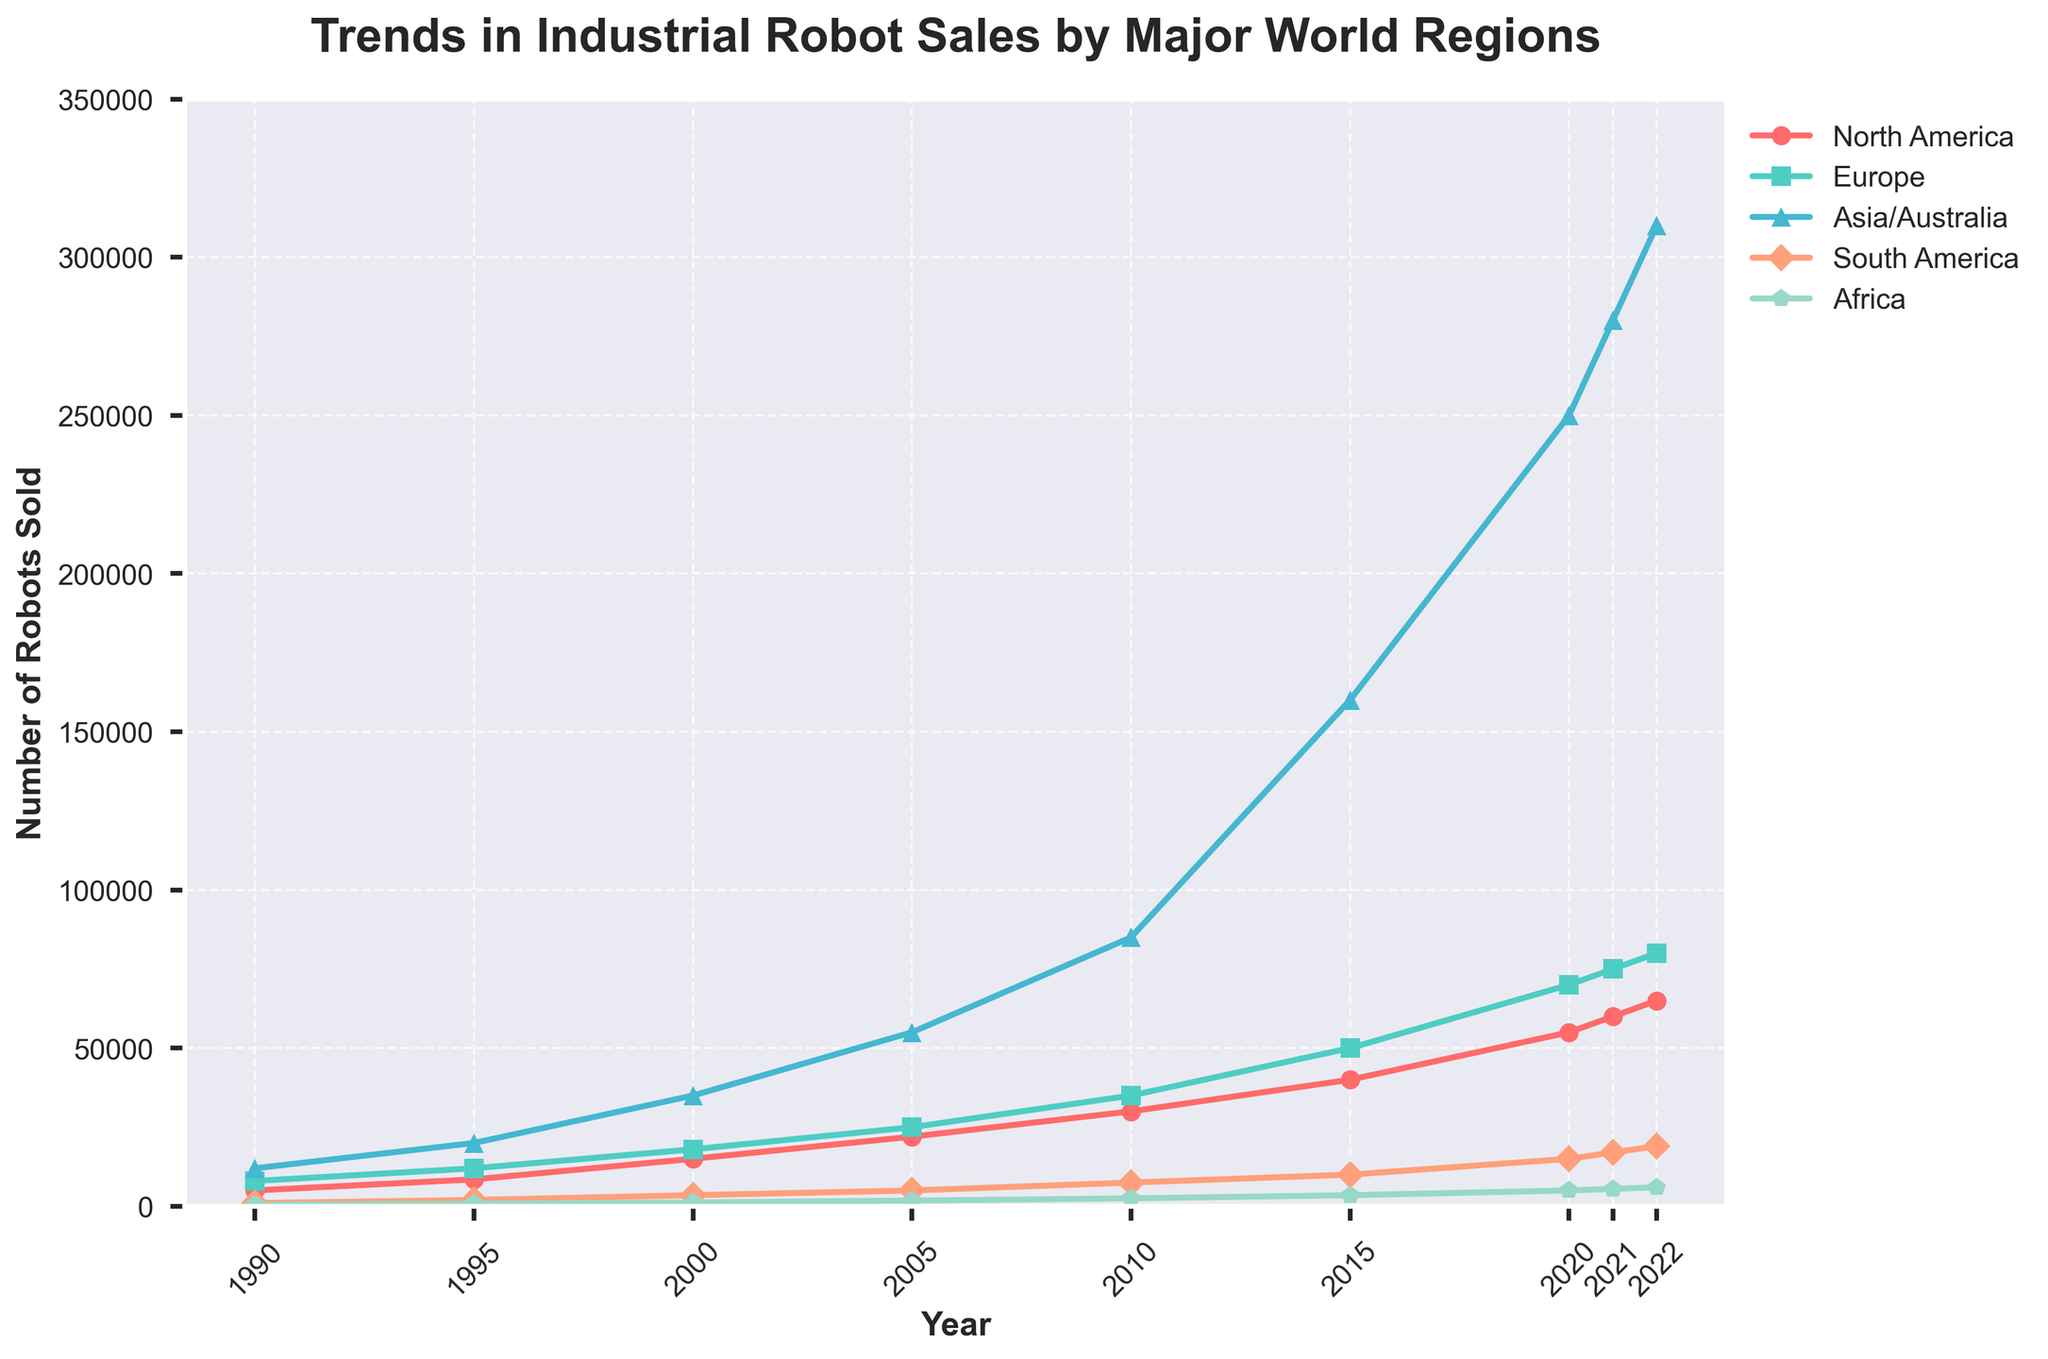What's the trend in industrial robot sales in Asia/Australia from 1990 to 2022? Examine the line for Asia/Australia, which starts at 12,000 in 1990 and ends at 310,000 in 2022, showing a consistent and steep increase over the period.
Answer: Increasing Which region had the highest growth in robot sales between 1995 and 2000? To find the region with the highest growth, calculate the difference between 2000 and 1995 for each region. Asia/Australia had the highest increase, from 20,000 to 35,000, an increment of 15,000.
Answer: Asia/Australia Between 2010 and 2015, which regions had an increase in robot sales? By comparing the data between 2010 and 2015: North America (30,000 to 40,000), Europe (35,000 to 50,000), Asia/Australia (85,000 to 160,000), South America (7,500 to 10,000), and Africa (2,500 to 3,500). All regions show an increase.
Answer: North America, Europe, Asia/Australia, South America, Africa What's the difference in robot sales between Europe and South America in 2020? Comparing the figures for 2020: Europe (70,000) and South America (15,000). Subtract the two to get the difference: 70,000 - 15,000 = 55,000.
Answer: 55,000 Throughout the years, which region always had the lowest robot sales? By observing the trends visually, Africa consistently had the lowest sales figures from 1990 to 2022.
Answer: Africa How does the robot sales trend in North America compare visually to Europe? Both North America and Europe show an increasing trend, but Europe's sales are consistently higher than North America's throughout the period, with both regions showing the steepest rise after 2005.
Answer: Europe's sales are higher and both are increasing In which year did Asia/Australia surpass 100,000 robot sales? Following the line for Asia/Australia, it crosses the 100,000 mark between 2010 (85,000) and 2015 (160,000). Hence, it surpasses 100,000 in 2015.
Answer: 2015 Which region showed the most dramatic increase in robot sales after 2005? Comparing the slopes of the lines post-2005, Asia/Australia exhibits the most dramatic increase, going from 55,000 in 2005 to 310,000 in 2022.
Answer: Asia/Australia What's the combined total of robot sales in 2022 for North America and Europe? Adding the figures for 2022: North America (65,000) and Europe (80,000), the total is 65,000 + 80,000 = 145,000.
Answer: 145,000 